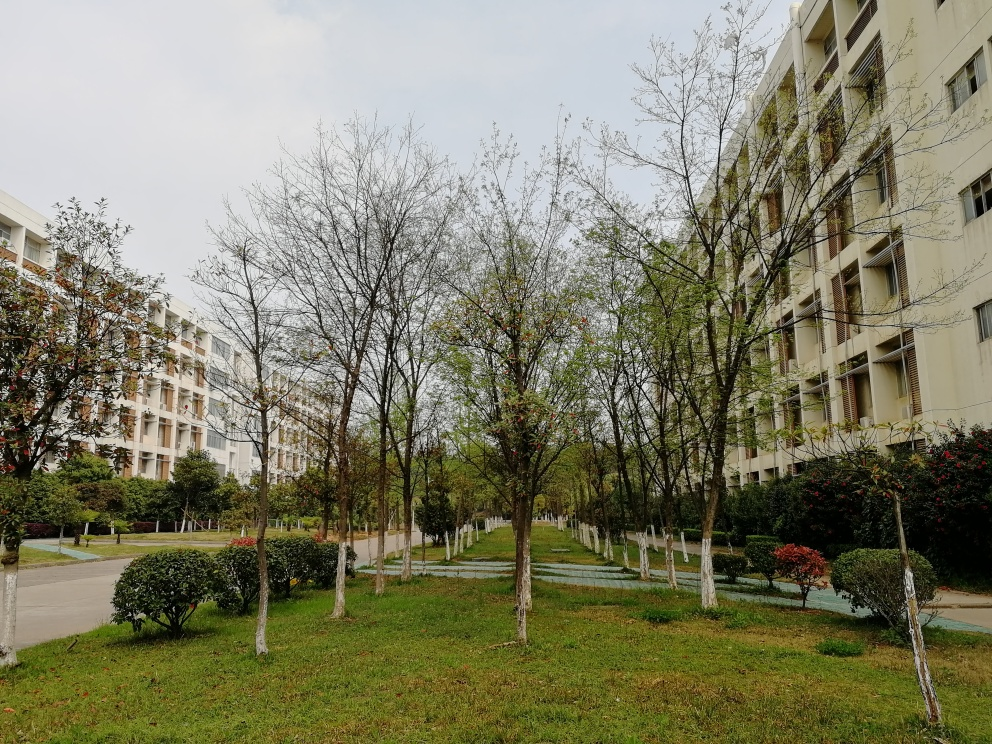What is the overall quality of the photo? The photo is of average quality. It captures the scene in sufficient detail with balanced lighting, but lacks standout features that might elevate it to a higher quality rating. The composition is standard without any unique perspectives or elements that draw the viewer's eye, and the image could benefit from a clearer focus or a more dynamic range of colors. 